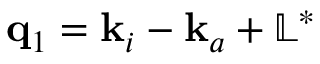<formula> <loc_0><loc_0><loc_500><loc_500>q _ { 1 } = k _ { i } - k _ { a } + \mathbb { L } ^ { * }</formula> 